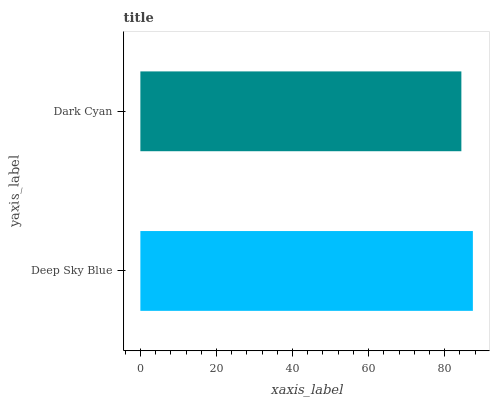Is Dark Cyan the minimum?
Answer yes or no. Yes. Is Deep Sky Blue the maximum?
Answer yes or no. Yes. Is Dark Cyan the maximum?
Answer yes or no. No. Is Deep Sky Blue greater than Dark Cyan?
Answer yes or no. Yes. Is Dark Cyan less than Deep Sky Blue?
Answer yes or no. Yes. Is Dark Cyan greater than Deep Sky Blue?
Answer yes or no. No. Is Deep Sky Blue less than Dark Cyan?
Answer yes or no. No. Is Deep Sky Blue the high median?
Answer yes or no. Yes. Is Dark Cyan the low median?
Answer yes or no. Yes. Is Dark Cyan the high median?
Answer yes or no. No. Is Deep Sky Blue the low median?
Answer yes or no. No. 